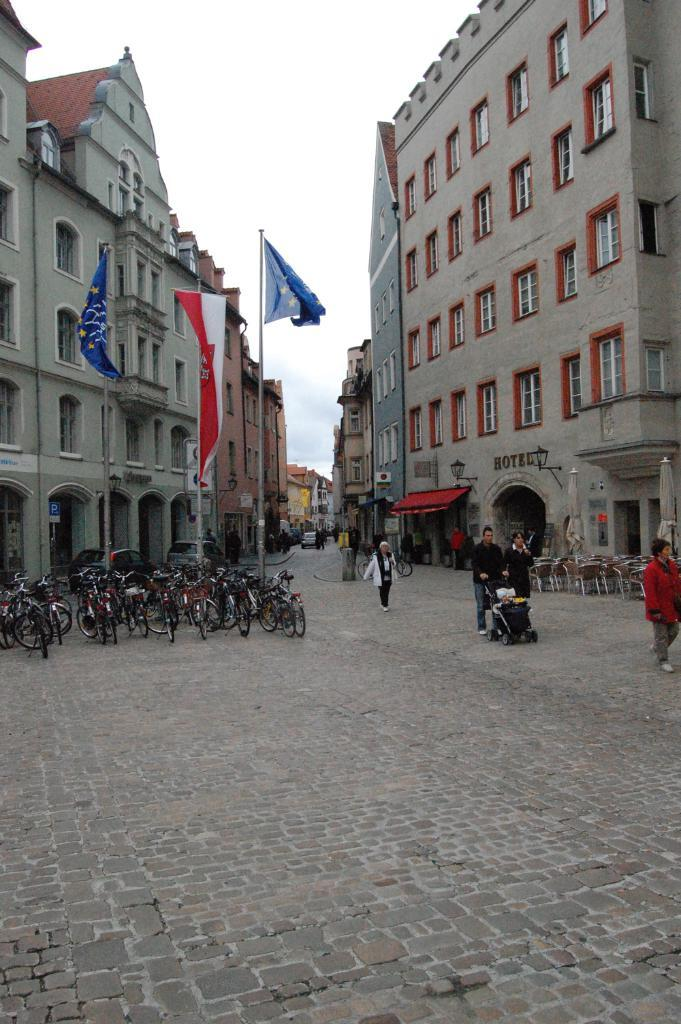What type of structures can be seen in the image? There are buildings in the image. What type of furniture is visible in the image? There are chairs in the image. Who or what is present in the image? There are people in the image. What mode of transportation can be seen in the image? There are bicycles in the image. What type of symbol or emblem is present in the image? There are flags in the image. What is visible at the top of the image? The sky is visible at the top of the image. How many bottles are visible in the image? There are no bottles present in the image. What is the distance between the buildings in the image? The provided facts do not give information about the distance between the buildings, so it cannot be determined from the image. 